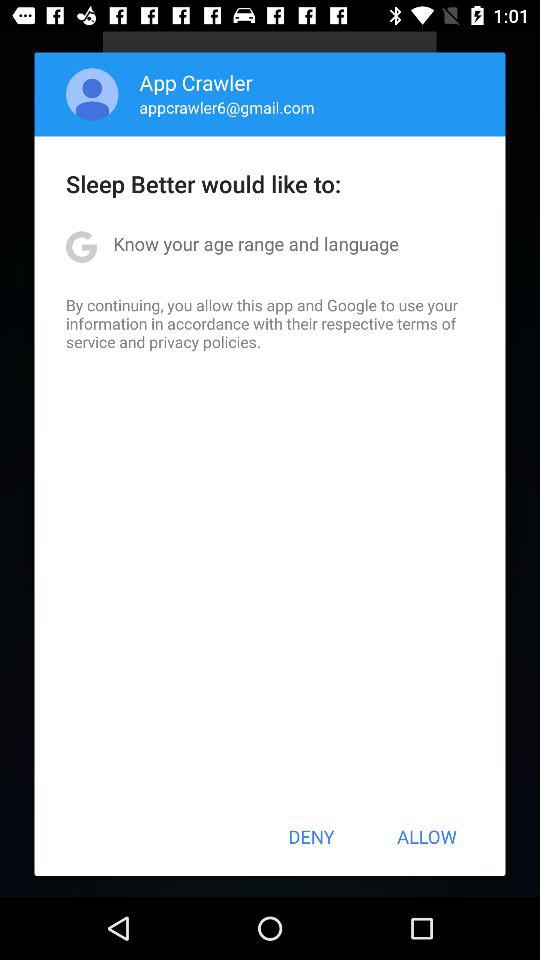What is the email address? The email address is "appcrawler6@gmail.com". 